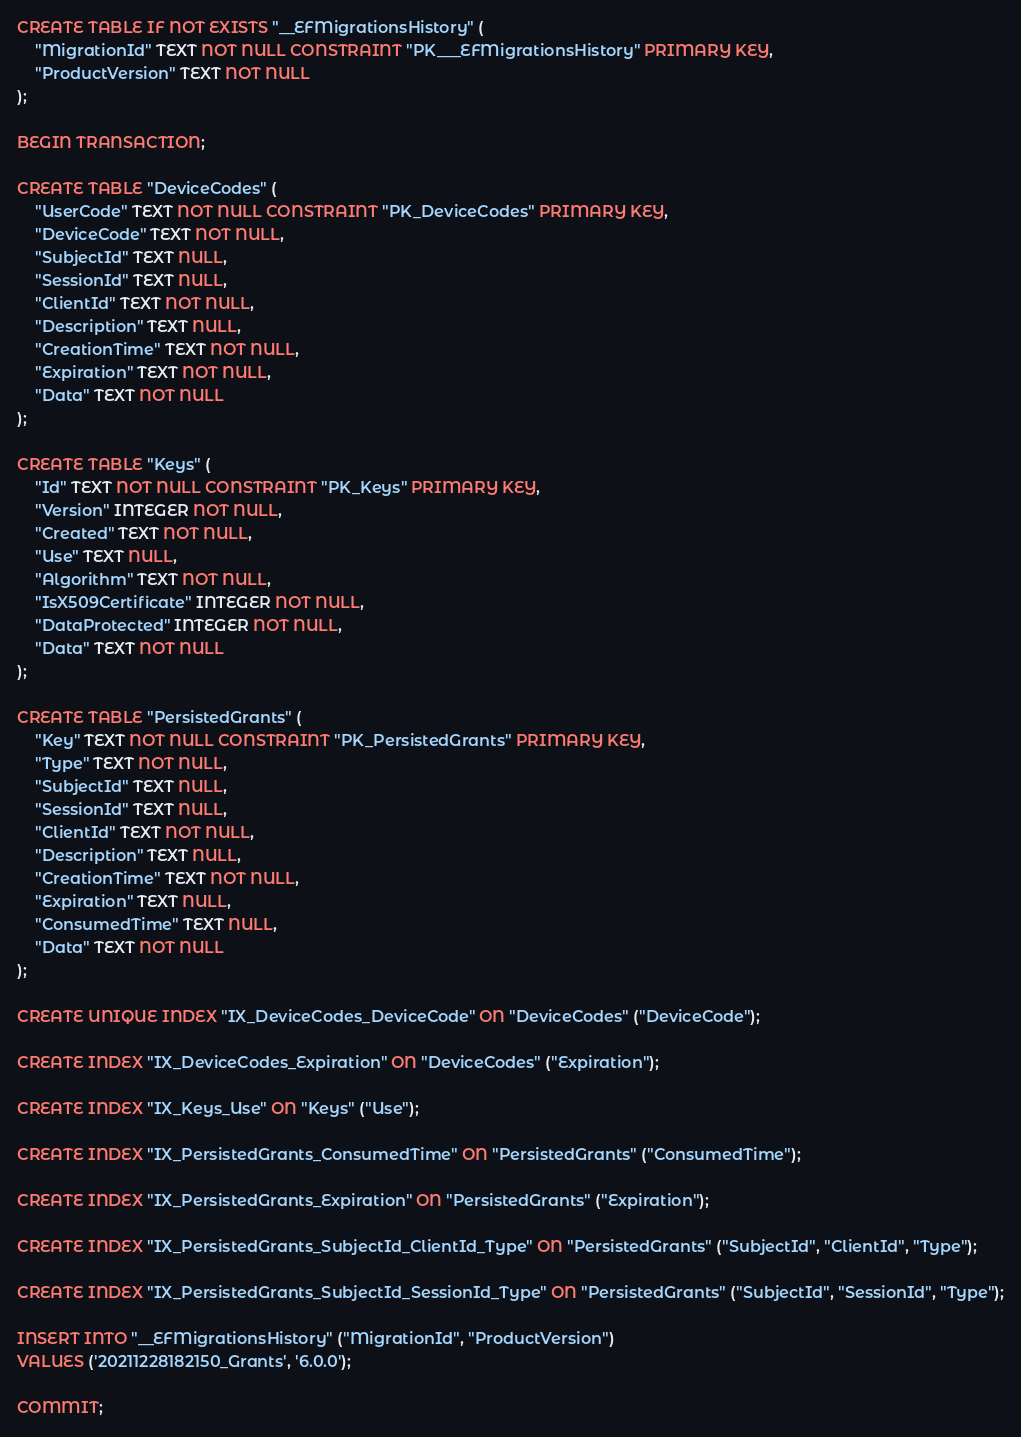<code> <loc_0><loc_0><loc_500><loc_500><_SQL_>CREATE TABLE IF NOT EXISTS "__EFMigrationsHistory" (
    "MigrationId" TEXT NOT NULL CONSTRAINT "PK___EFMigrationsHistory" PRIMARY KEY,
    "ProductVersion" TEXT NOT NULL
);

BEGIN TRANSACTION;

CREATE TABLE "DeviceCodes" (
    "UserCode" TEXT NOT NULL CONSTRAINT "PK_DeviceCodes" PRIMARY KEY,
    "DeviceCode" TEXT NOT NULL,
    "SubjectId" TEXT NULL,
    "SessionId" TEXT NULL,
    "ClientId" TEXT NOT NULL,
    "Description" TEXT NULL,
    "CreationTime" TEXT NOT NULL,
    "Expiration" TEXT NOT NULL,
    "Data" TEXT NOT NULL
);

CREATE TABLE "Keys" (
    "Id" TEXT NOT NULL CONSTRAINT "PK_Keys" PRIMARY KEY,
    "Version" INTEGER NOT NULL,
    "Created" TEXT NOT NULL,
    "Use" TEXT NULL,
    "Algorithm" TEXT NOT NULL,
    "IsX509Certificate" INTEGER NOT NULL,
    "DataProtected" INTEGER NOT NULL,
    "Data" TEXT NOT NULL
);

CREATE TABLE "PersistedGrants" (
    "Key" TEXT NOT NULL CONSTRAINT "PK_PersistedGrants" PRIMARY KEY,
    "Type" TEXT NOT NULL,
    "SubjectId" TEXT NULL,
    "SessionId" TEXT NULL,
    "ClientId" TEXT NOT NULL,
    "Description" TEXT NULL,
    "CreationTime" TEXT NOT NULL,
    "Expiration" TEXT NULL,
    "ConsumedTime" TEXT NULL,
    "Data" TEXT NOT NULL
);

CREATE UNIQUE INDEX "IX_DeviceCodes_DeviceCode" ON "DeviceCodes" ("DeviceCode");

CREATE INDEX "IX_DeviceCodes_Expiration" ON "DeviceCodes" ("Expiration");

CREATE INDEX "IX_Keys_Use" ON "Keys" ("Use");

CREATE INDEX "IX_PersistedGrants_ConsumedTime" ON "PersistedGrants" ("ConsumedTime");

CREATE INDEX "IX_PersistedGrants_Expiration" ON "PersistedGrants" ("Expiration");

CREATE INDEX "IX_PersistedGrants_SubjectId_ClientId_Type" ON "PersistedGrants" ("SubjectId", "ClientId", "Type");

CREATE INDEX "IX_PersistedGrants_SubjectId_SessionId_Type" ON "PersistedGrants" ("SubjectId", "SessionId", "Type");

INSERT INTO "__EFMigrationsHistory" ("MigrationId", "ProductVersion")
VALUES ('20211228182150_Grants', '6.0.0');

COMMIT;

</code> 